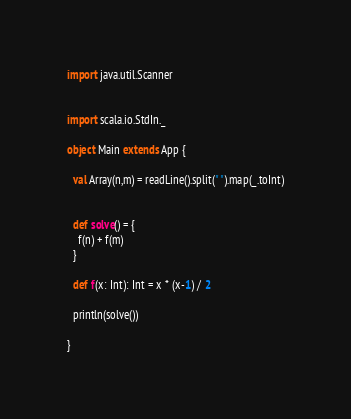Convert code to text. <code><loc_0><loc_0><loc_500><loc_500><_Scala_>import java.util.Scanner


import scala.io.StdIn._

object Main extends App {

  val Array(n,m) = readLine().split(" ").map(_.toInt)


  def solve() = {
    f(n) + f(m)
  }

  def f(x: Int): Int = x * (x-1) / 2

  println(solve())

}

</code> 